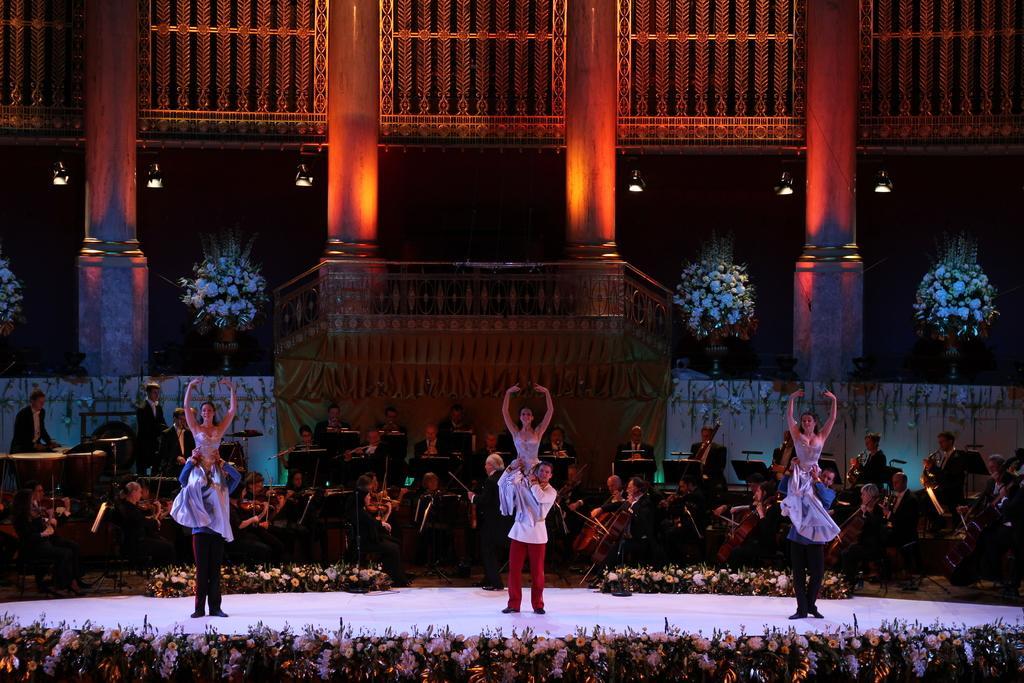How would you summarize this image in a sentence or two? In this image I can see there are few persons dancing on the stage and the stage is decorated with flowers. And few are playing musical instruments. And at the back there is a building with flower pots. 